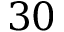Convert formula to latex. <formula><loc_0><loc_0><loc_500><loc_500>3 0</formula> 